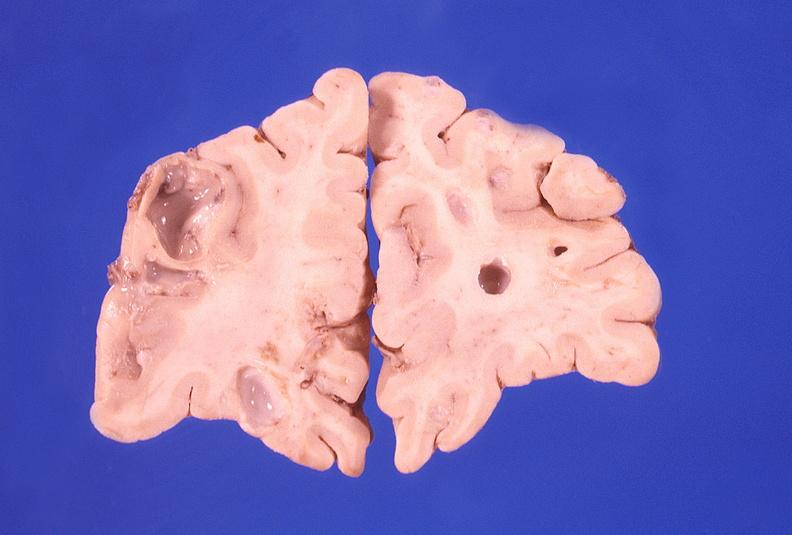s apoptosis tunel present?
Answer the question using a single word or phrase. No 